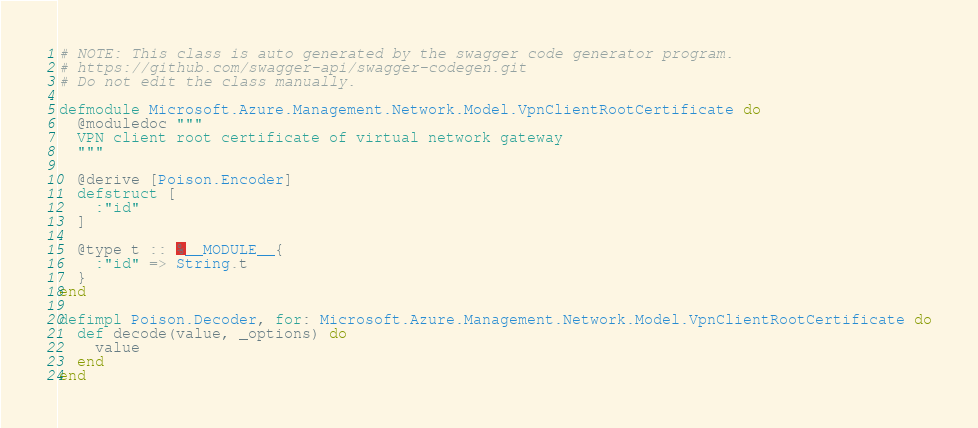Convert code to text. <code><loc_0><loc_0><loc_500><loc_500><_Elixir_># NOTE: This class is auto generated by the swagger code generator program.
# https://github.com/swagger-api/swagger-codegen.git
# Do not edit the class manually.

defmodule Microsoft.Azure.Management.Network.Model.VpnClientRootCertificate do
  @moduledoc """
  VPN client root certificate of virtual network gateway
  """

  @derive [Poison.Encoder]
  defstruct [
    :"id"
  ]

  @type t :: %__MODULE__{
    :"id" => String.t
  }
end

defimpl Poison.Decoder, for: Microsoft.Azure.Management.Network.Model.VpnClientRootCertificate do
  def decode(value, _options) do
    value
  end
end

</code> 